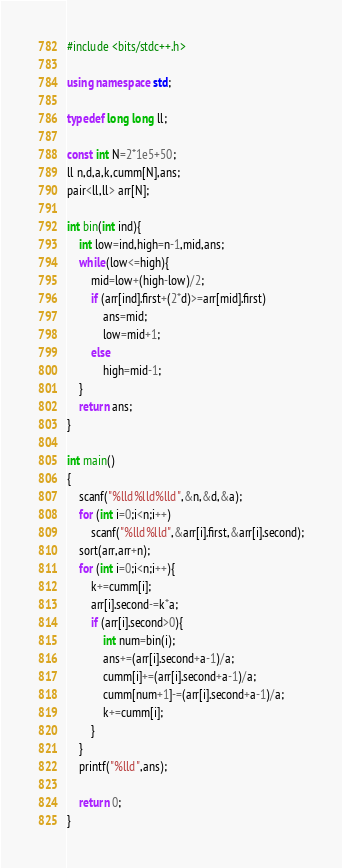Convert code to text. <code><loc_0><loc_0><loc_500><loc_500><_C++_>#include <bits/stdc++.h>

using namespace std;

typedef long long ll;

const int N=2*1e5+50;
ll n,d,a,k,cumm[N],ans;
pair<ll,ll> arr[N];

int bin(int ind){
    int low=ind,high=n-1,mid,ans;
    while(low<=high){
        mid=low+(high-low)/2;
        if (arr[ind].first+(2*d)>=arr[mid].first)
            ans=mid;
            low=mid+1;
        else
            high=mid-1;
    }
    return ans;
}

int main()
{
    scanf("%lld%lld%lld",&n,&d,&a);
    for (int i=0;i<n;i++)
        scanf("%lld%lld",&arr[i].first,&arr[i].second);
    sort(arr,arr+n);
    for (int i=0;i<n;i++){
        k+=cumm[i];
        arr[i].second-=k*a;
        if (arr[i].second>0){
            int num=bin(i);
            ans+=(arr[i].second+a-1)/a;
            cumm[i]+=(arr[i].second+a-1)/a;
            cumm[num+1]-=(arr[i].second+a-1)/a;
            k+=cumm[i];
        }
    }
    printf("%lld",ans);

    return 0;
}</code> 